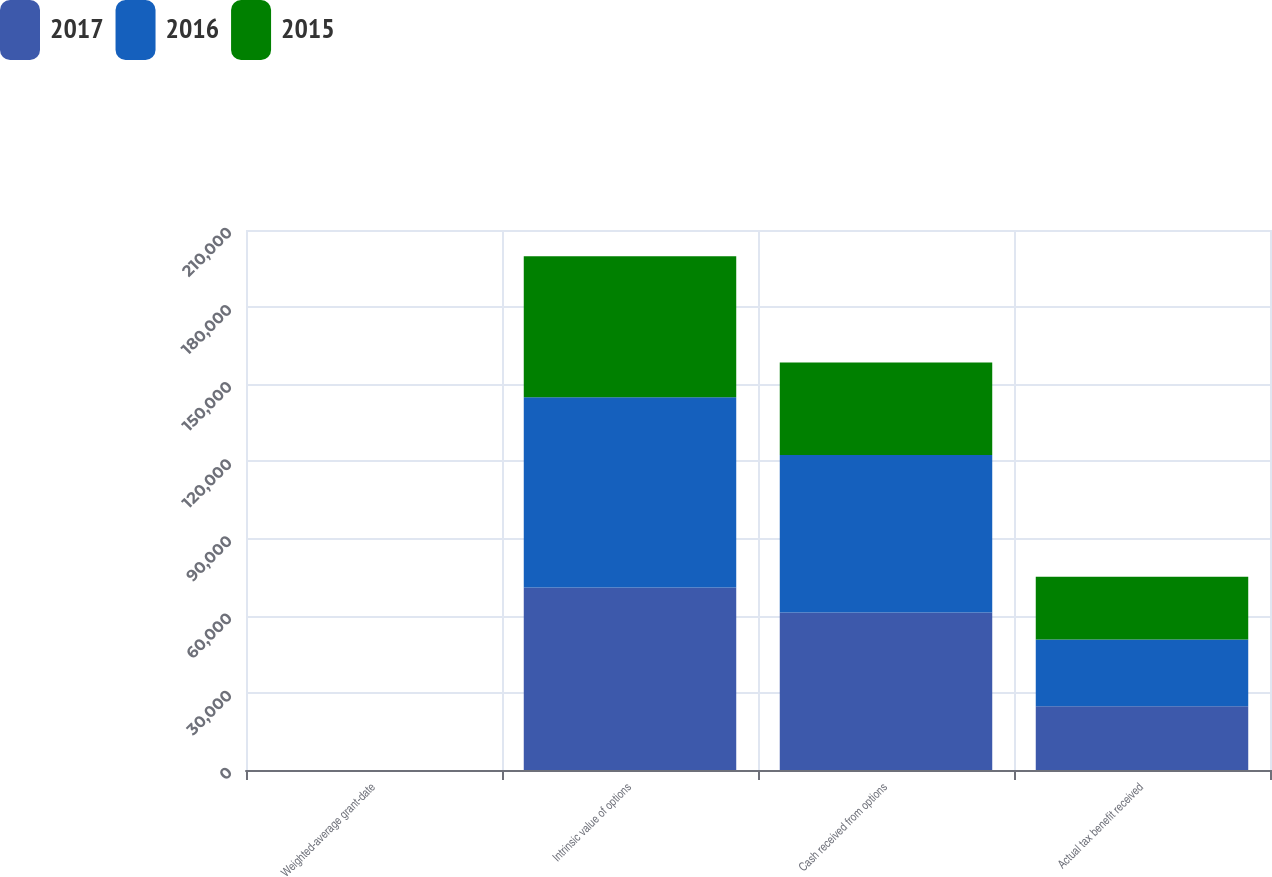Convert chart. <chart><loc_0><loc_0><loc_500><loc_500><stacked_bar_chart><ecel><fcel>Weighted-average grant-date<fcel>Intrinsic value of options<fcel>Cash received from options<fcel>Actual tax benefit received<nl><fcel>2017<fcel>12.88<fcel>70948<fcel>61215<fcel>24832<nl><fcel>2016<fcel>9.04<fcel>73995<fcel>61329<fcel>25898<nl><fcel>2015<fcel>11.97<fcel>54854<fcel>35958<fcel>24470<nl></chart> 